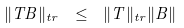<formula> <loc_0><loc_0><loc_500><loc_500>\| T B \| _ { t r } \ \leq \ \| T \| _ { t r } \| B \|</formula> 